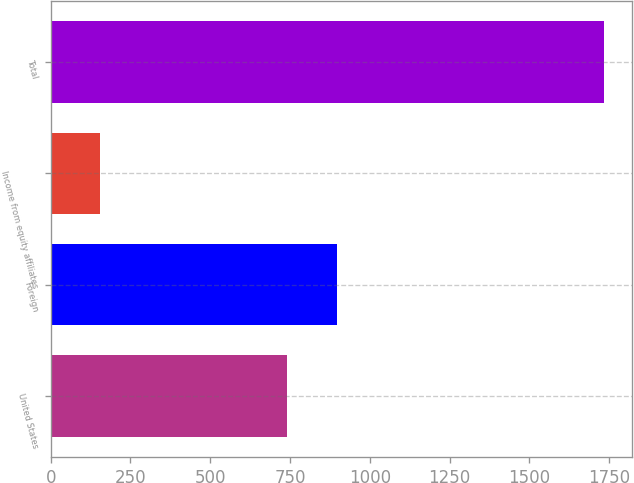<chart> <loc_0><loc_0><loc_500><loc_500><bar_chart><fcel>United States<fcel>Foreign<fcel>Income from equity affiliates<fcel>Total<nl><fcel>739<fcel>896.9<fcel>154.5<fcel>1733.5<nl></chart> 